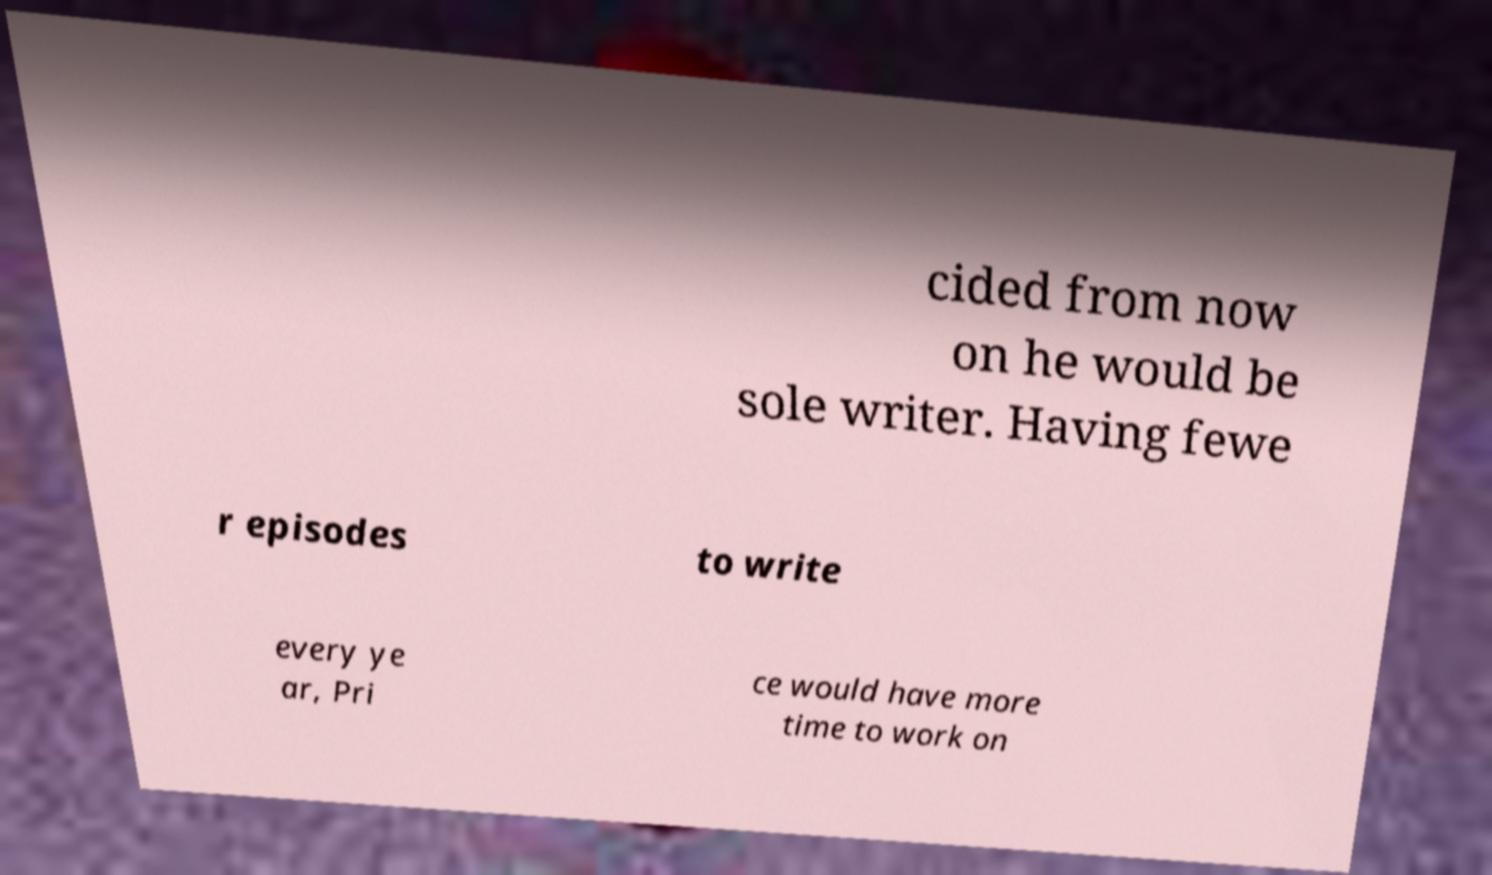Could you extract and type out the text from this image? cided from now on he would be sole writer. Having fewe r episodes to write every ye ar, Pri ce would have more time to work on 